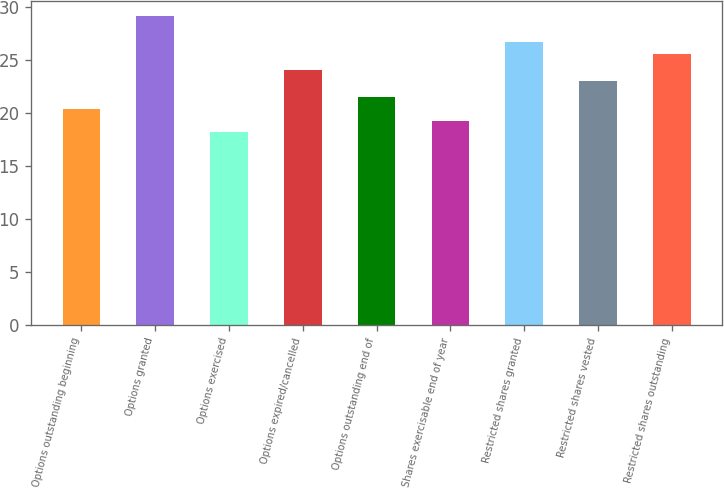Convert chart to OTSL. <chart><loc_0><loc_0><loc_500><loc_500><bar_chart><fcel>Options outstanding beginning<fcel>Options granted<fcel>Options exercised<fcel>Options expired/cancelled<fcel>Options outstanding end of<fcel>Shares exercisable end of year<fcel>Restricted shares granted<fcel>Restricted shares vested<fcel>Restricted shares outstanding<nl><fcel>20.35<fcel>29.11<fcel>18.17<fcel>24.05<fcel>21.44<fcel>19.26<fcel>26.69<fcel>22.96<fcel>25.54<nl></chart> 